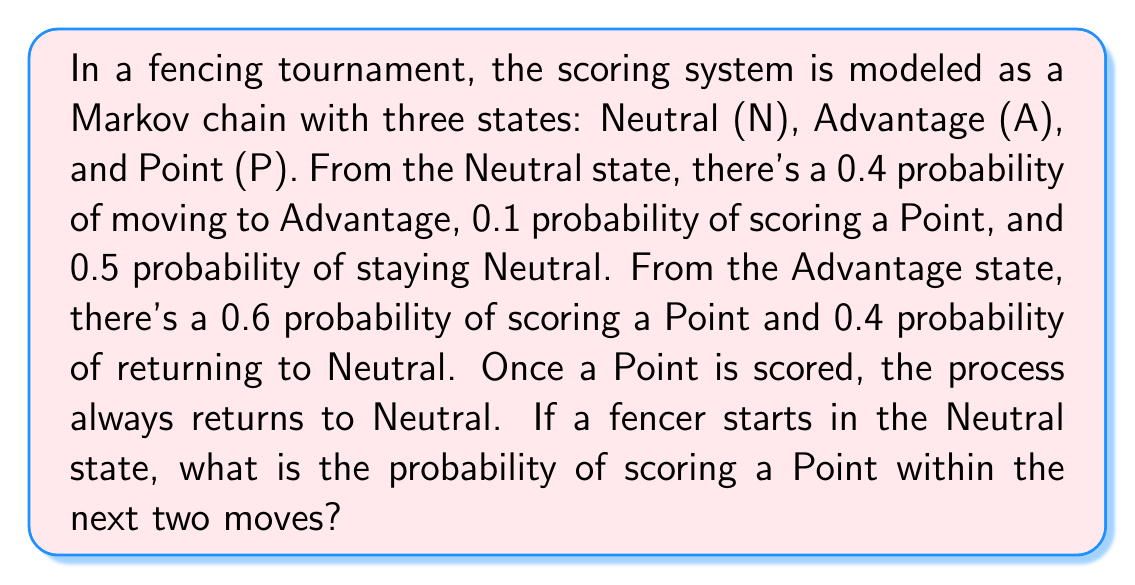Can you solve this math problem? Let's approach this step-by-step:

1) First, we need to identify the possible paths to score a Point within two moves:
   a) N → P (direct point)
   b) N → A → P (advantage then point)

2) Let's calculate the probability of each path:

   a) N → P: 
      Probability = 0.1

   b) N → A → P:
      Probability = P(N → A) * P(A → P)
                  = 0.4 * 0.6 = 0.24

3) The total probability is the sum of these two probabilities:

   P(scoring a Point within two moves) = P(N → P) + P(N → A → P)
                                       = 0.1 + 0.24 = 0.34

4) We can verify this using the transition matrix method:

   The transition matrix P is:

   $$P = \begin{bmatrix}
   0.5 & 0.4 & 0.1 \\
   0.4 & 0 & 0.6 \\
   1 & 0 & 0
   \end{bmatrix}$$

   The initial state vector is $\pi_0 = [1 \; 0 \; 0]$ (starting in Neutral)

   After one move: $\pi_1 = \pi_0 P = [0.5 \; 0.4 \; 0.1]$
   After two moves: $\pi_2 = \pi_1 P = [0.66 \; 0.24 \; 0.34]$

   The probability of being in the Point state after two moves is 0.34, confirming our calculation.
Answer: 0.34 